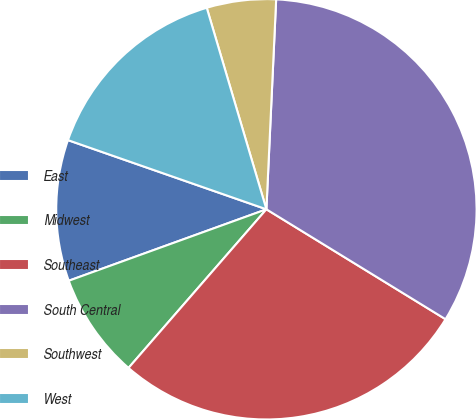Convert chart to OTSL. <chart><loc_0><loc_0><loc_500><loc_500><pie_chart><fcel>East<fcel>Midwest<fcel>Southeast<fcel>South Central<fcel>Southwest<fcel>West<nl><fcel>10.86%<fcel>8.09%<fcel>27.63%<fcel>33.02%<fcel>5.32%<fcel>15.08%<nl></chart> 